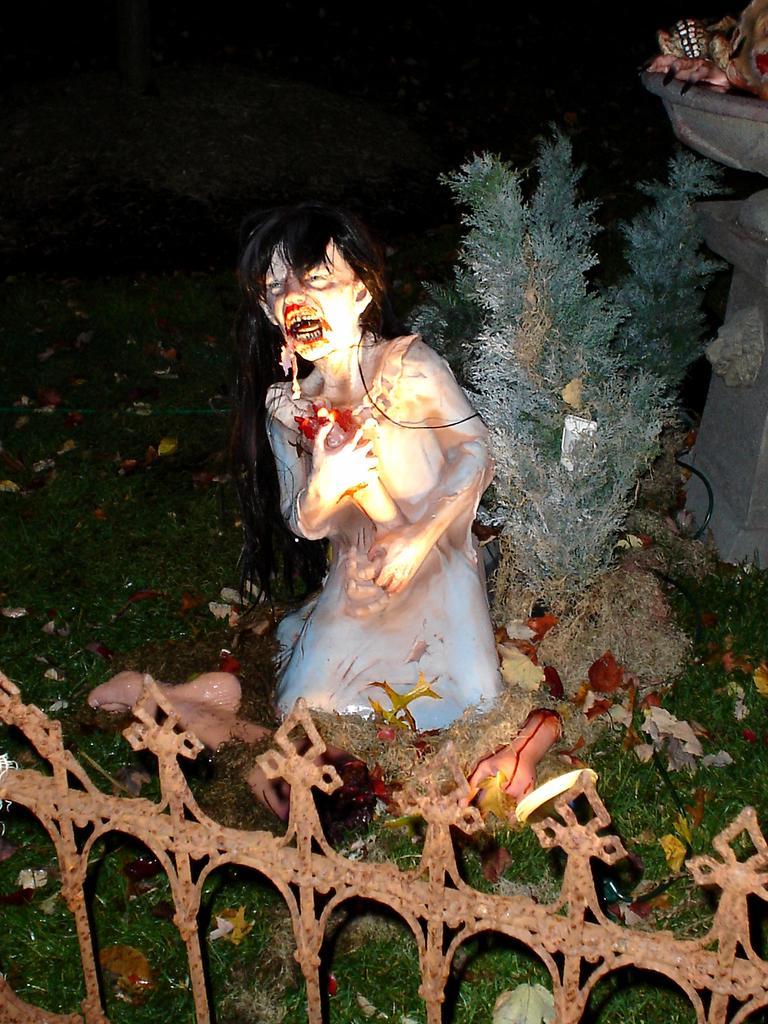Please provide a concise description of this image. In this image there is a railing, behind the railing there is a grassland, on that there is a sculpture, plant and a fountain. 